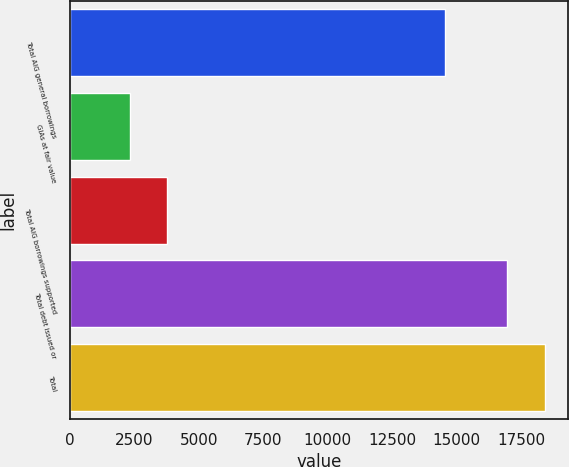Convert chart. <chart><loc_0><loc_0><loc_500><loc_500><bar_chart><fcel>Total AIG general borrowings<fcel>GIAs at fair value<fcel>Total AIG borrowings supported<fcel>Total debt issued or<fcel>Total<nl><fcel>14545<fcel>2315<fcel>3778.8<fcel>16953<fcel>18416.8<nl></chart> 